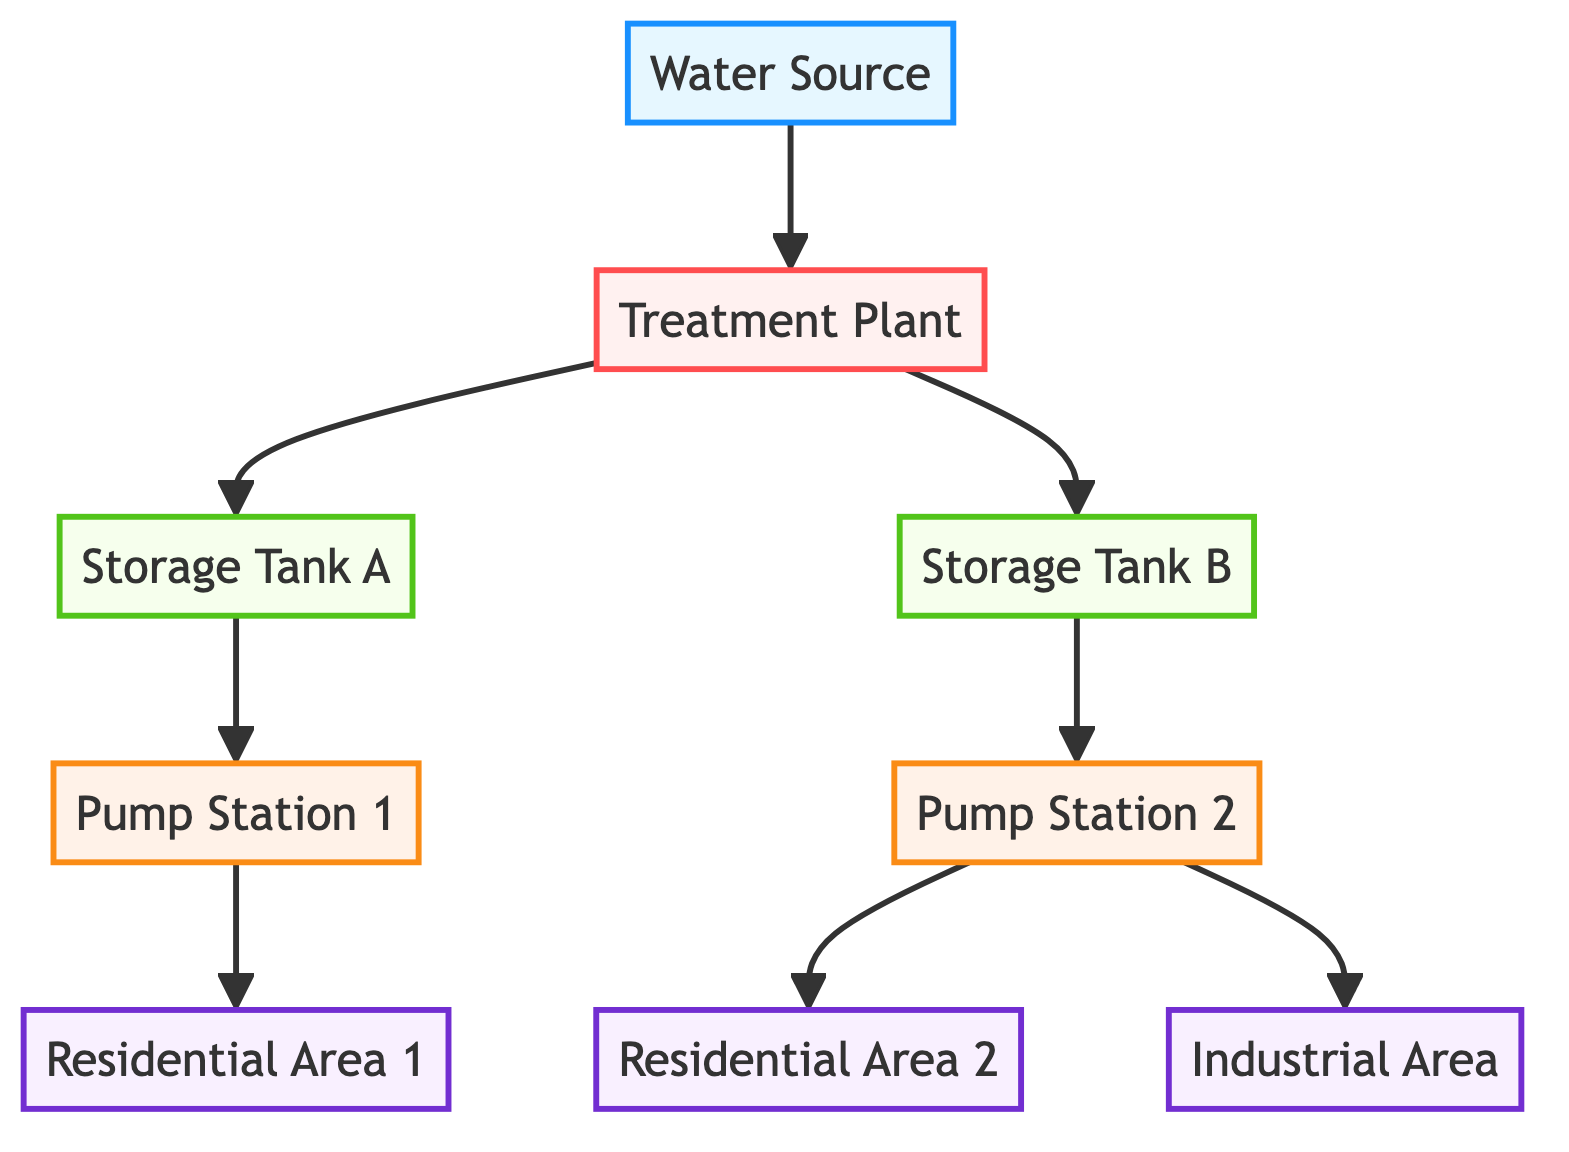What is the starting point of the water flow? The diagram indicates that the water flow begins at the "Water Source," which is the primary source of water. This is directly linked to the treatment plant as the first connection in the graph.
Answer: Water Source How many storage tanks are shown in the diagram? The diagram features two storage tanks: "Storage Tank A" and "Storage Tank B." Counting the nodes labeled as storage reveals a total of two tanks.
Answer: 2 Which pump station distributes water from Storage Tank A? The relationship in the diagram shows that "Pump Station 1" is directly connected to "Storage Tank A," indicating it is responsible for pumping water from this tank.
Answer: Pump Station 1 What is the flow direction from the treatment plant? The treatment plant has two outgoing edges: one towards "Storage Tank A" and another towards "Storage Tank B." Therefore, the flow direction is both to these storage tanks, indicating the processed water flows to both locations.
Answer: "Storage Tank A" and "Storage Tank B" How many demand nodes are there in total? The diagram identifies three demand nodes: "Residential Area 1," "Residential Area 2," and the "Industrial Area." Counting these reveals a total of three demand areas.
Answer: 3 Which areas receive water from Pump Station 2? Examining the outgoing connections from "Pump Station 2" shows two arrows directing towards "Residential Area 2" and the "Industrial Area." Therefore, these are the areas supplied by this pump station.
Answer: Residential Area 2 and Industrial Area What is the relationship between the treatment plant and Storage Tank B? The edge connecting the "Treatment Plant" to "Storage Tank B" indicates that treated water is sent to this storage tank. This relationship represents the process of moving treated water from the plant to storage facilities.
Answer: Treated water is sent What type of facility is the treatment plant classified as? The diagram classifies the "Treatment Plant" as a processing facility. This classification is indicated by the node's properties in the graph.
Answer: Processing Which two areas receive water from Pump Station 2? Analyzing the connections from "Pump Station 2," it indicates water flows out to both "Residential Area 2" and the "Industrial Area." Thus, these two areas are served by this particular pump station.
Answer: Residential Area 2 and Industrial Area 